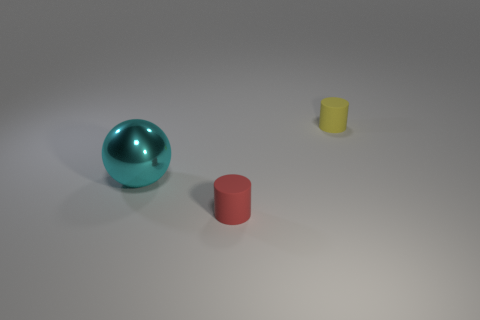Add 3 cyan balls. How many objects exist? 6 Subtract all cylinders. How many objects are left? 1 Add 3 large cyan metal balls. How many large cyan metal balls are left? 4 Add 1 green shiny cubes. How many green shiny cubes exist? 1 Subtract 1 red cylinders. How many objects are left? 2 Subtract all gray cylinders. Subtract all blue blocks. How many cylinders are left? 2 Subtract all large cyan shiny cylinders. Subtract all matte cylinders. How many objects are left? 1 